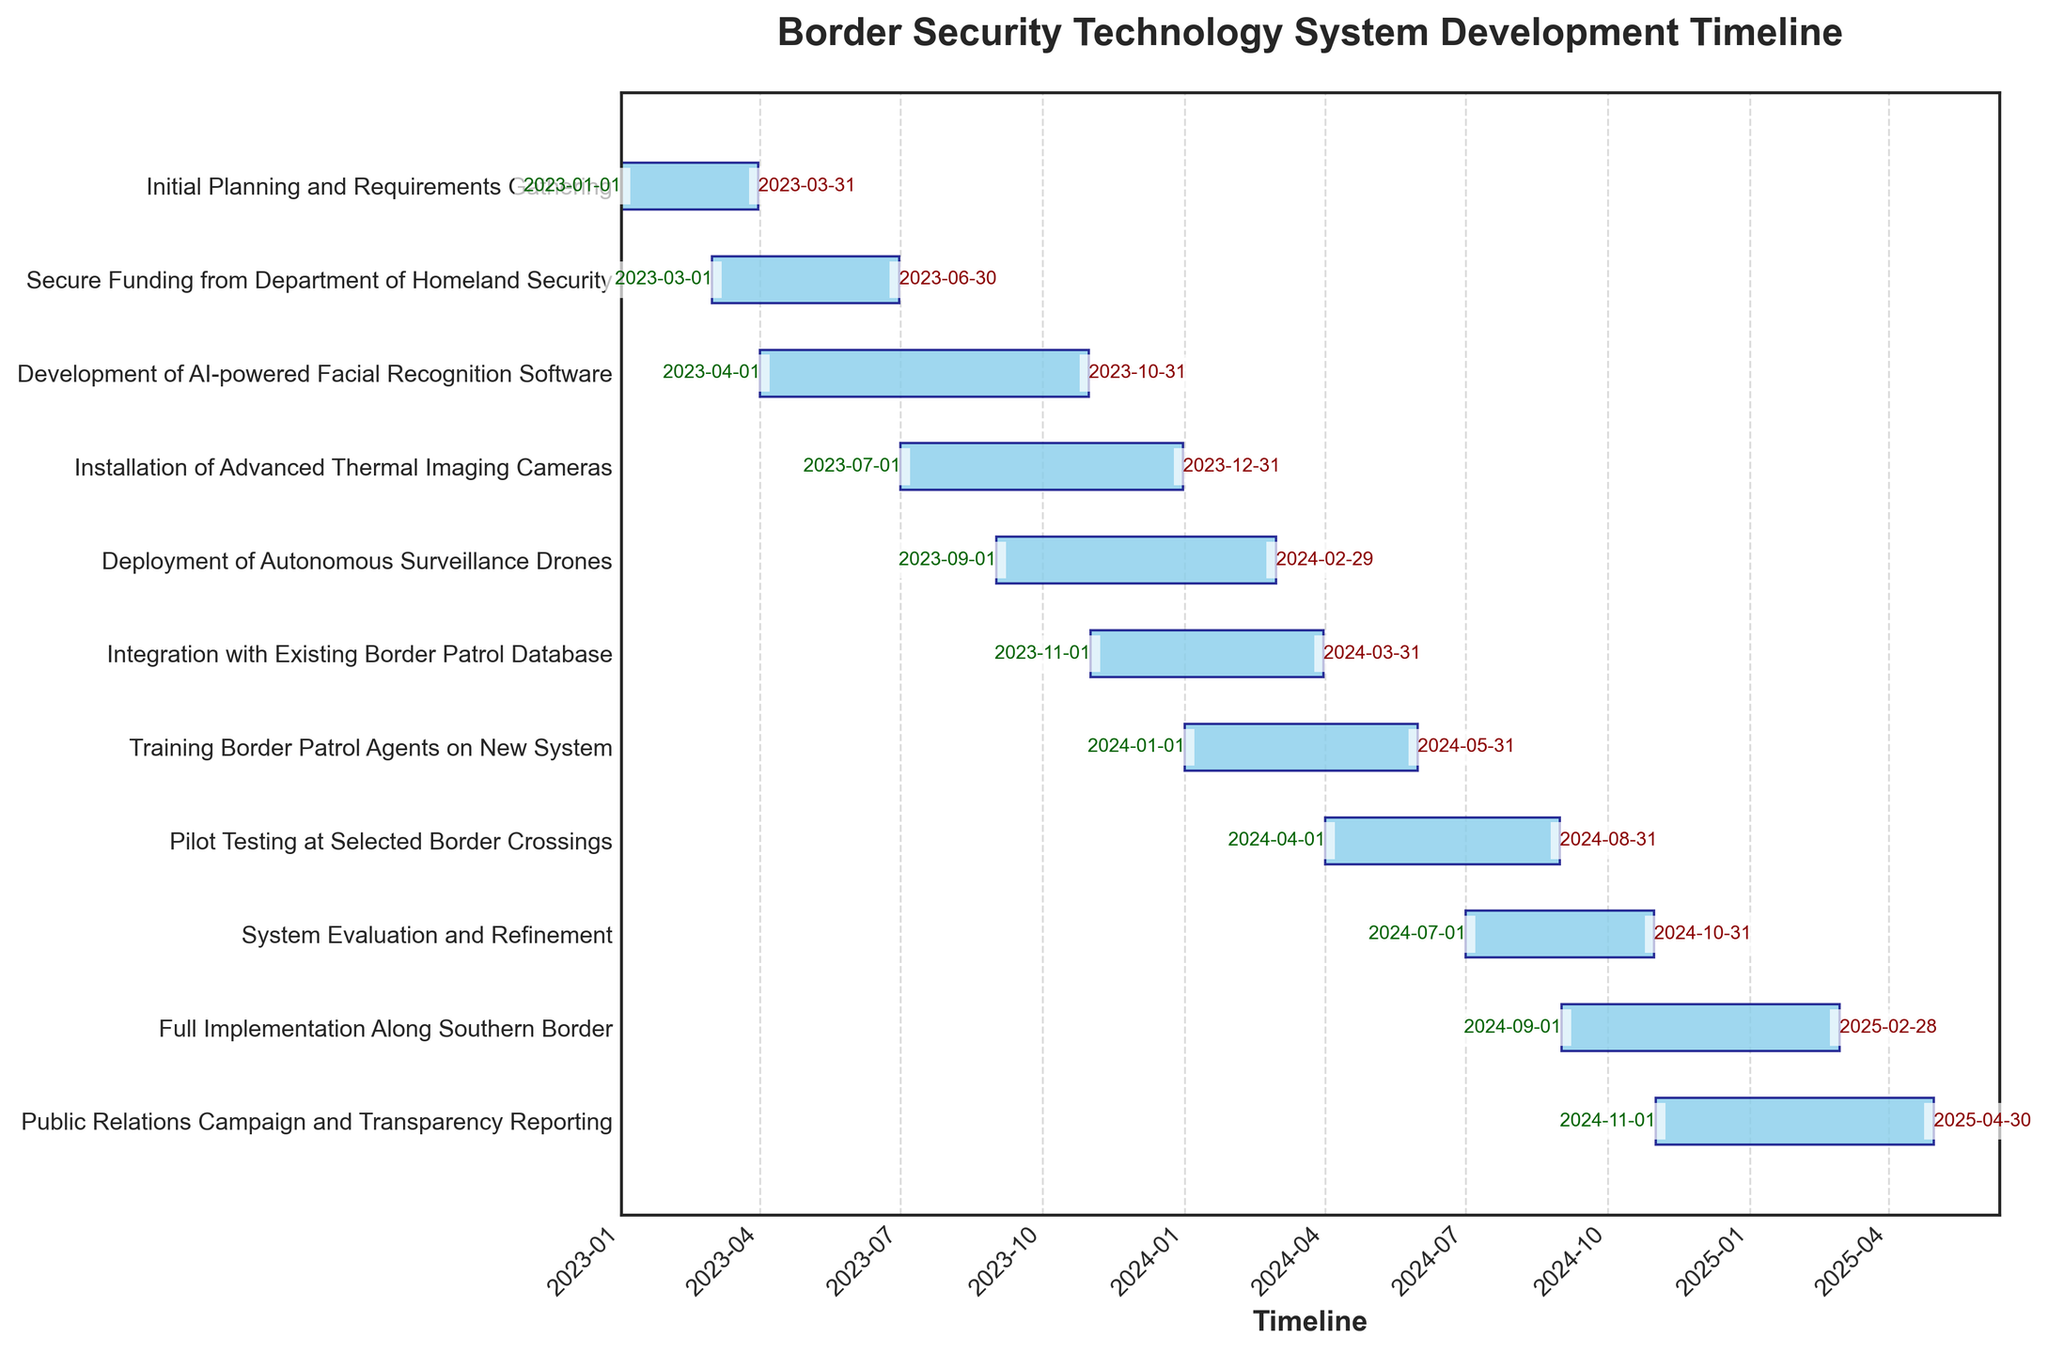What is the title of the Gantt Chart? The title of the Gantt Chart is displayed at the top center of the figure in bold text. By looking at that section, we can read the title.
Answer: Border Security Technology System Development Timeline What are the x-axis and y-axis labels? The x-axis label is shown horizontally below the axis and describes the timeline represented in the plot, whereas the y-axis label isn't explicitly stated but consists of the task descriptions listed vertically.
Answer: Timeline (x-axis); Task names (y-axis) How many tasks are listed in the Gantt Chart? Count the number of unique task descriptions that appear as labels along the y-axis. Each task name represents a separate task.
Answer: 11 When does the "Development of AI-powered Facial Recognition Software" task start and end? Locate the bar labeled "Development of AI-powered Facial Recognition Software" on the y-axis. Read the start date from the beginning of the bar and the end date from the end of the bar.
Answer: 2023-04-01 to 2023-10-31 Which task has the longest duration, and how long is it? Find the task with the longest horizontal bar width, indicating the longest duration. Calculate the number of days between the start and end dates of that task.
Answer: Public Relations Campaign and Transparency Reporting, 6 months What tasks are ongoing during November 2023? Identify the tasks with bars that cover the month of November 2023 within their range (inclusive of start and end dates).
Answer: Development of AI-powered Facial Recognition Software, Installation of Advanced Thermal Imaging Cameras, Deployment of Autonomous Surveillance Drones, Integration with Existing Border Patrol Database What is the duration of "Training Border Patrol Agents on New System" in months? Calculate the difference in months between the start and end dates of the "Training Border Patrol Agents on New System" task.
Answer: 5 months Which task ends the latest, and when does it end? Locate the task with the end date that appears farthest to the right on the x-axis. This indicates the latest end date.
Answer: Public Relations Campaign and Transparency Reporting, 2025-04-30 Are there any tasks that start before "Secure Funding from Department of Homeland Security" ends? Compare the end date of "Secure Funding from Department of Homeland Security" to the start dates of other tasks. Identify any tasks that start before this end date.
Answer: Development of AI-powered Facial Recognition Software What is the cumulative duration of all tasks in years? Sum the durations of all tasks in days and convert the total duration into years.
Answer: Approximately 5 years 